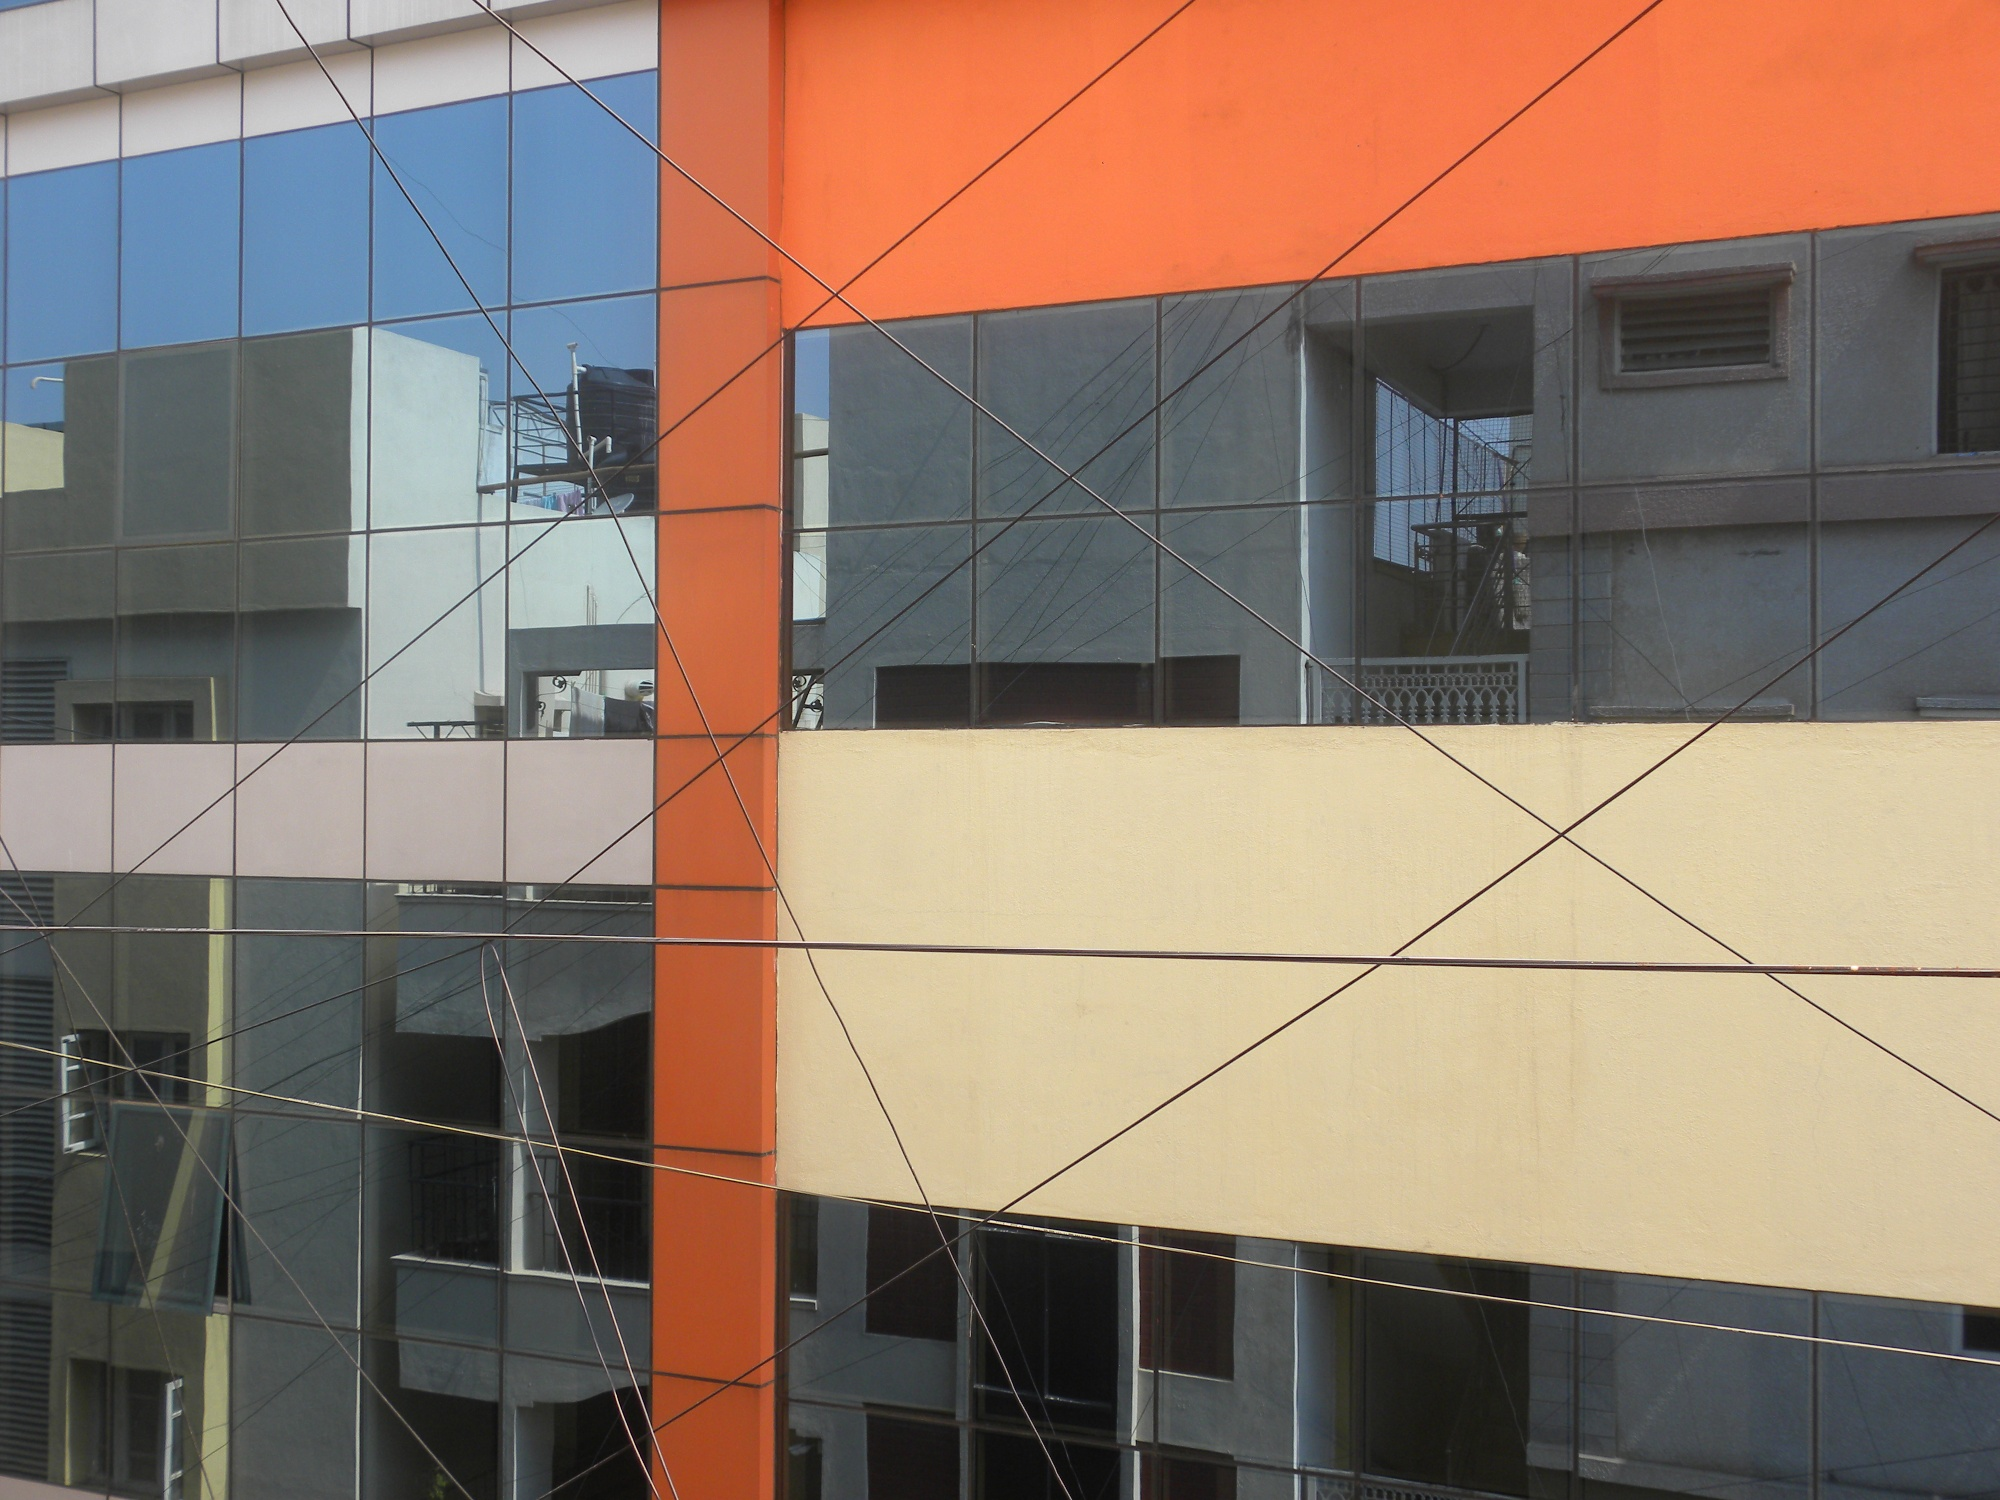How might this building adapt to environmental changes? This modern building, with its extensive glass windows and vibrant design, could adapt to environmental changes through several innovative approaches. For instance, the glass windows could be upgraded to smart glass technology, which adjusts transparency to control temperature and light, improving energy efficiency. The building could also incorporate green roofing on the balcony, utilizing plants to absorb rainwater, provide insulation, and create a micro-habitat for wildlife. Furthermore, solar panels could be installed to harness renewable energy, reducing the building’s carbon footprint and integrating it seamlessly into a sustainable urban ecosystem. 